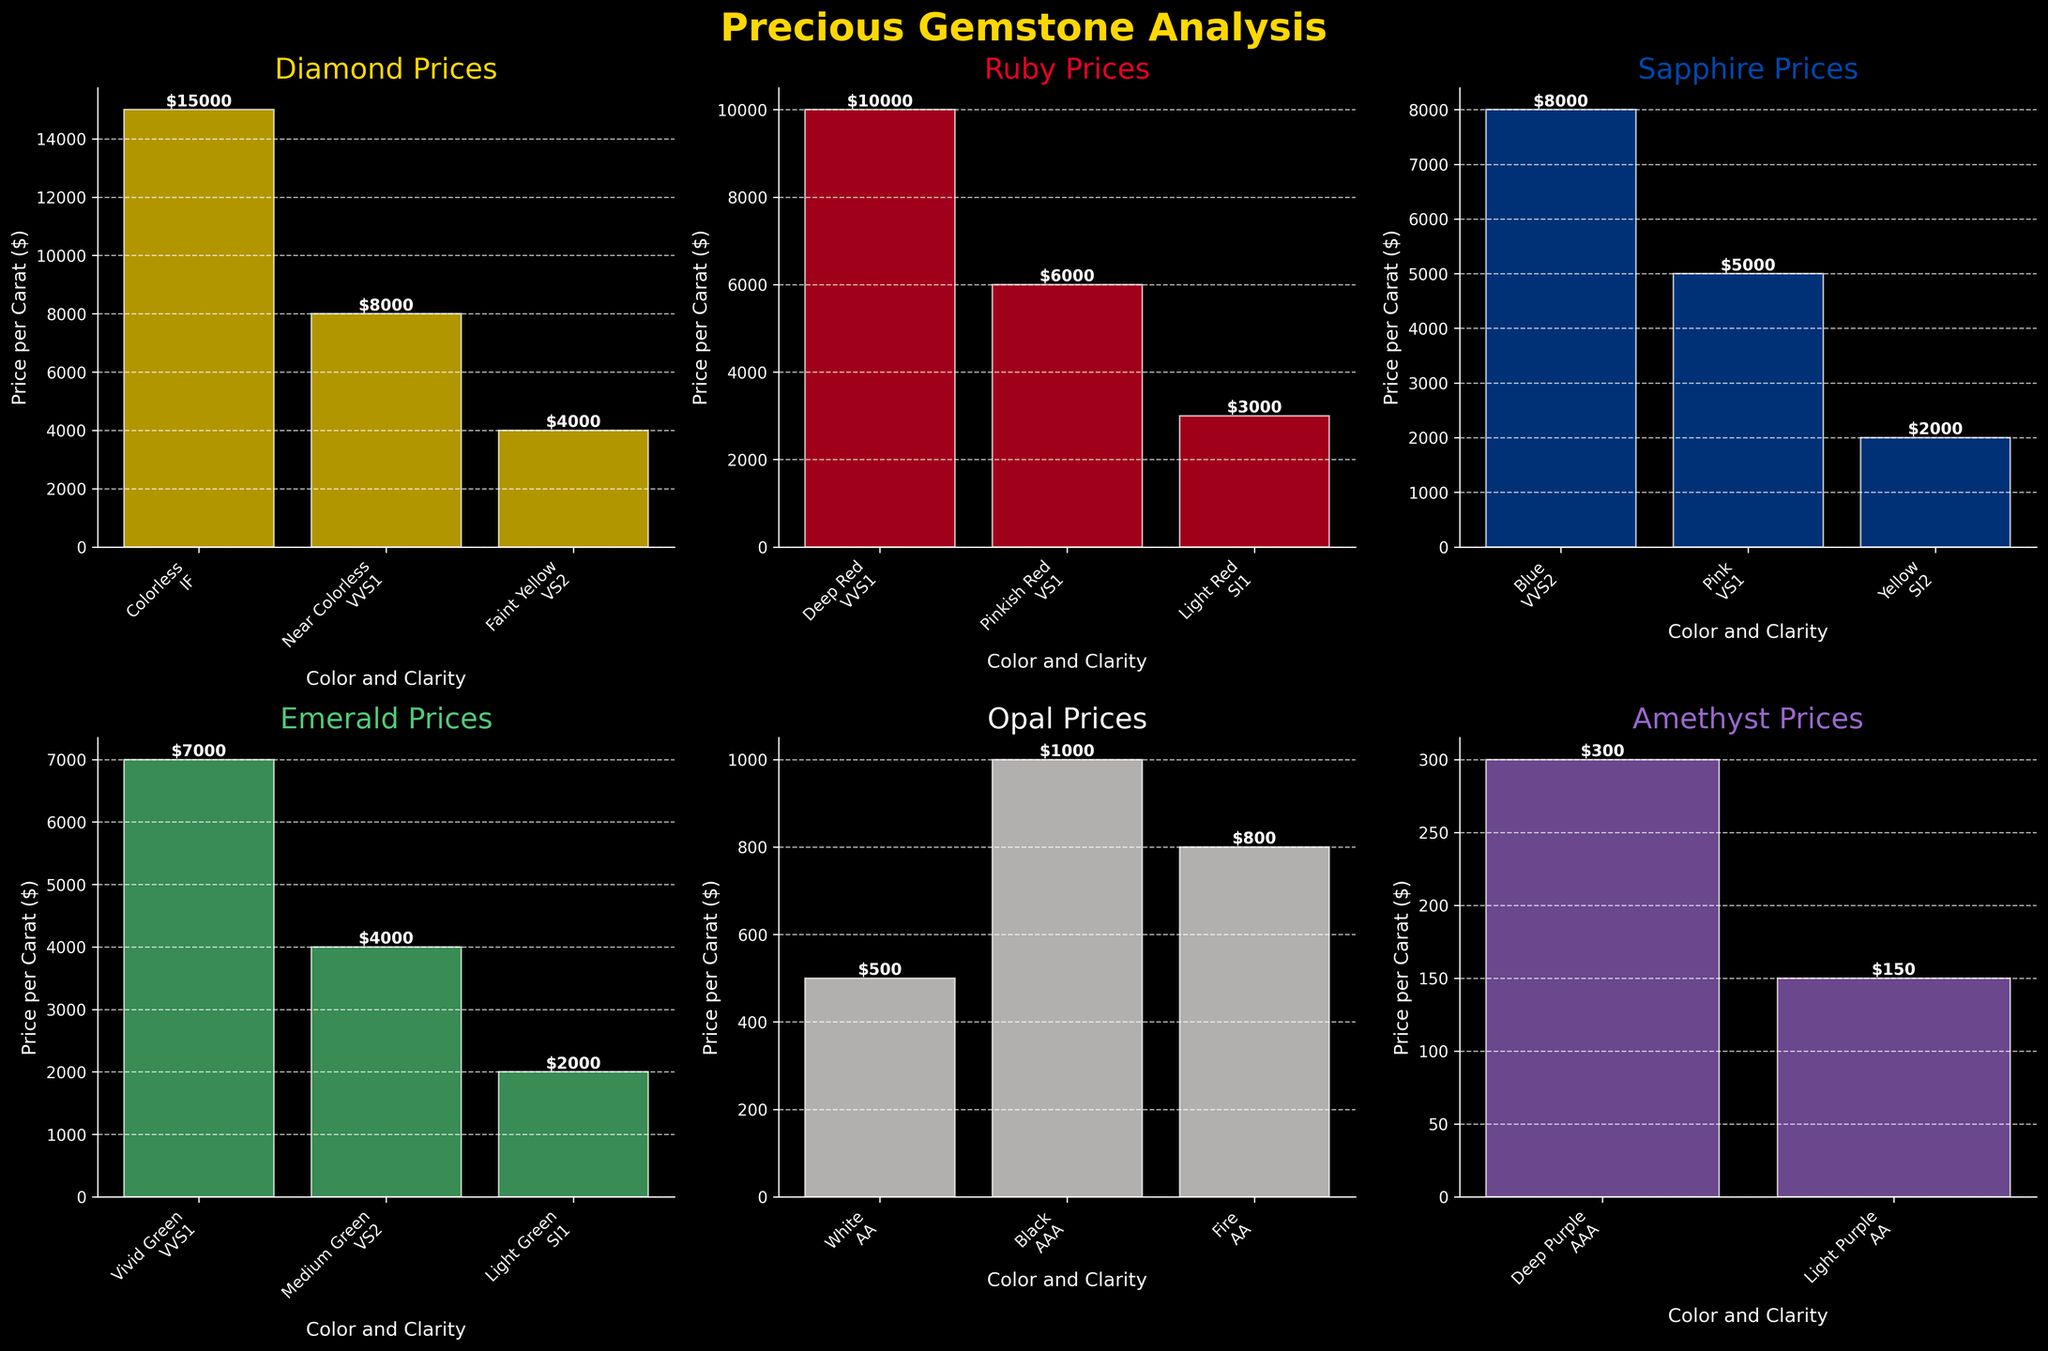How many types of gemstones are analyzed in the figure? The title "Precious Gemstone Analysis" and the six subplots indicate the number of gemstones analyzed. By counting the distinct gemstones in the subplots: Diamond, Ruby, Sapphire, Emerald, Opal, and Amethyst, the total is six types.
Answer: 6 For Ruby, which color and clarity combination has the highest price per carat? By examining the Ruby subplot, the tallest bar represents "Deep Red" with "VVS1" clarity. It has a price of \$10,000 per carat.
Answer: Deep Red, VVS1 What is the price difference between the highest and lowest priced diamonds? The subplot for Diamond shows the prices as \$15,000 (highest) and \$4,000 (lowest). The price difference is \$15,000 - \$4,000 = \$11,000.
Answer: \$11,000 Which gemstone has the overall highest price per carat, and what is its price? Scanning through all subplots, the tallest bar is in the Diamond subplot at \$15,000 per carat.
Answer: Diamond, \$15,000 Which subplots contain at least one gemstone priced below \$1,000 per carat? By checking all subplots, those for Opal and Amethyst contain bars below \$1,000. Opal has prices at \$500 and \$. Amethyst has prices at \$300 and \$150.
Answer: Opal, Amethyst What is the combined price of the highest priced Sapphire and Emerald per carat? Identifying the highest bars in both subplots, Sapphire has \$8,000 and Emerald has \$7,000. Summing them up: \$8,000 + \$7,000 = \$15,000.
Answer: \$15,000 Compare the clarity constraints and determine which gemstone has the most varied clarity options? By observing the labels on the x-axis of each subplot for clarity tags (IF, VVS1, VS2, etc.), Diamond has the most varied with "IF", "VVS1", "VS2" vs other gemstones which have more limited clarity variations.
Answer: Diamond Which gemstone is associated with the "Fire" category and what’s its price? In the Opal subplot by visually identifying categories, "Fire" is one of the color options. The price for it is \$800 per carat.
Answer: Opal, \$800 Between Ruby and Sapphire, which has the higher maximum price per carat? Ruby's maximum is \$10,000 per carat (Deep Red, VVS1). Sapphire’s maximum is \$8,000 per carat (Blue, VVS2).
Answer: Ruby 